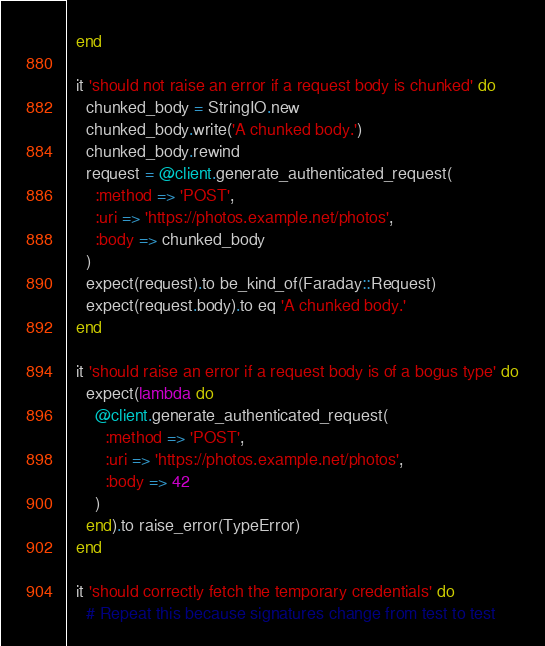<code> <loc_0><loc_0><loc_500><loc_500><_Ruby_>  end

  it 'should not raise an error if a request body is chunked' do
    chunked_body = StringIO.new
    chunked_body.write('A chunked body.')
    chunked_body.rewind
    request = @client.generate_authenticated_request(
      :method => 'POST',
      :uri => 'https://photos.example.net/photos',
      :body => chunked_body
    )
    expect(request).to be_kind_of(Faraday::Request)
    expect(request.body).to eq 'A chunked body.'
  end

  it 'should raise an error if a request body is of a bogus type' do
    expect(lambda do
      @client.generate_authenticated_request(
        :method => 'POST',
        :uri => 'https://photos.example.net/photos',
        :body => 42
      )
    end).to raise_error(TypeError)
  end

  it 'should correctly fetch the temporary credentials' do
    # Repeat this because signatures change from test to test</code> 